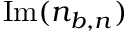<formula> <loc_0><loc_0><loc_500><loc_500>I m ( n _ { b , n } )</formula> 